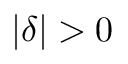<formula> <loc_0><loc_0><loc_500><loc_500>| \delta | > 0</formula> 